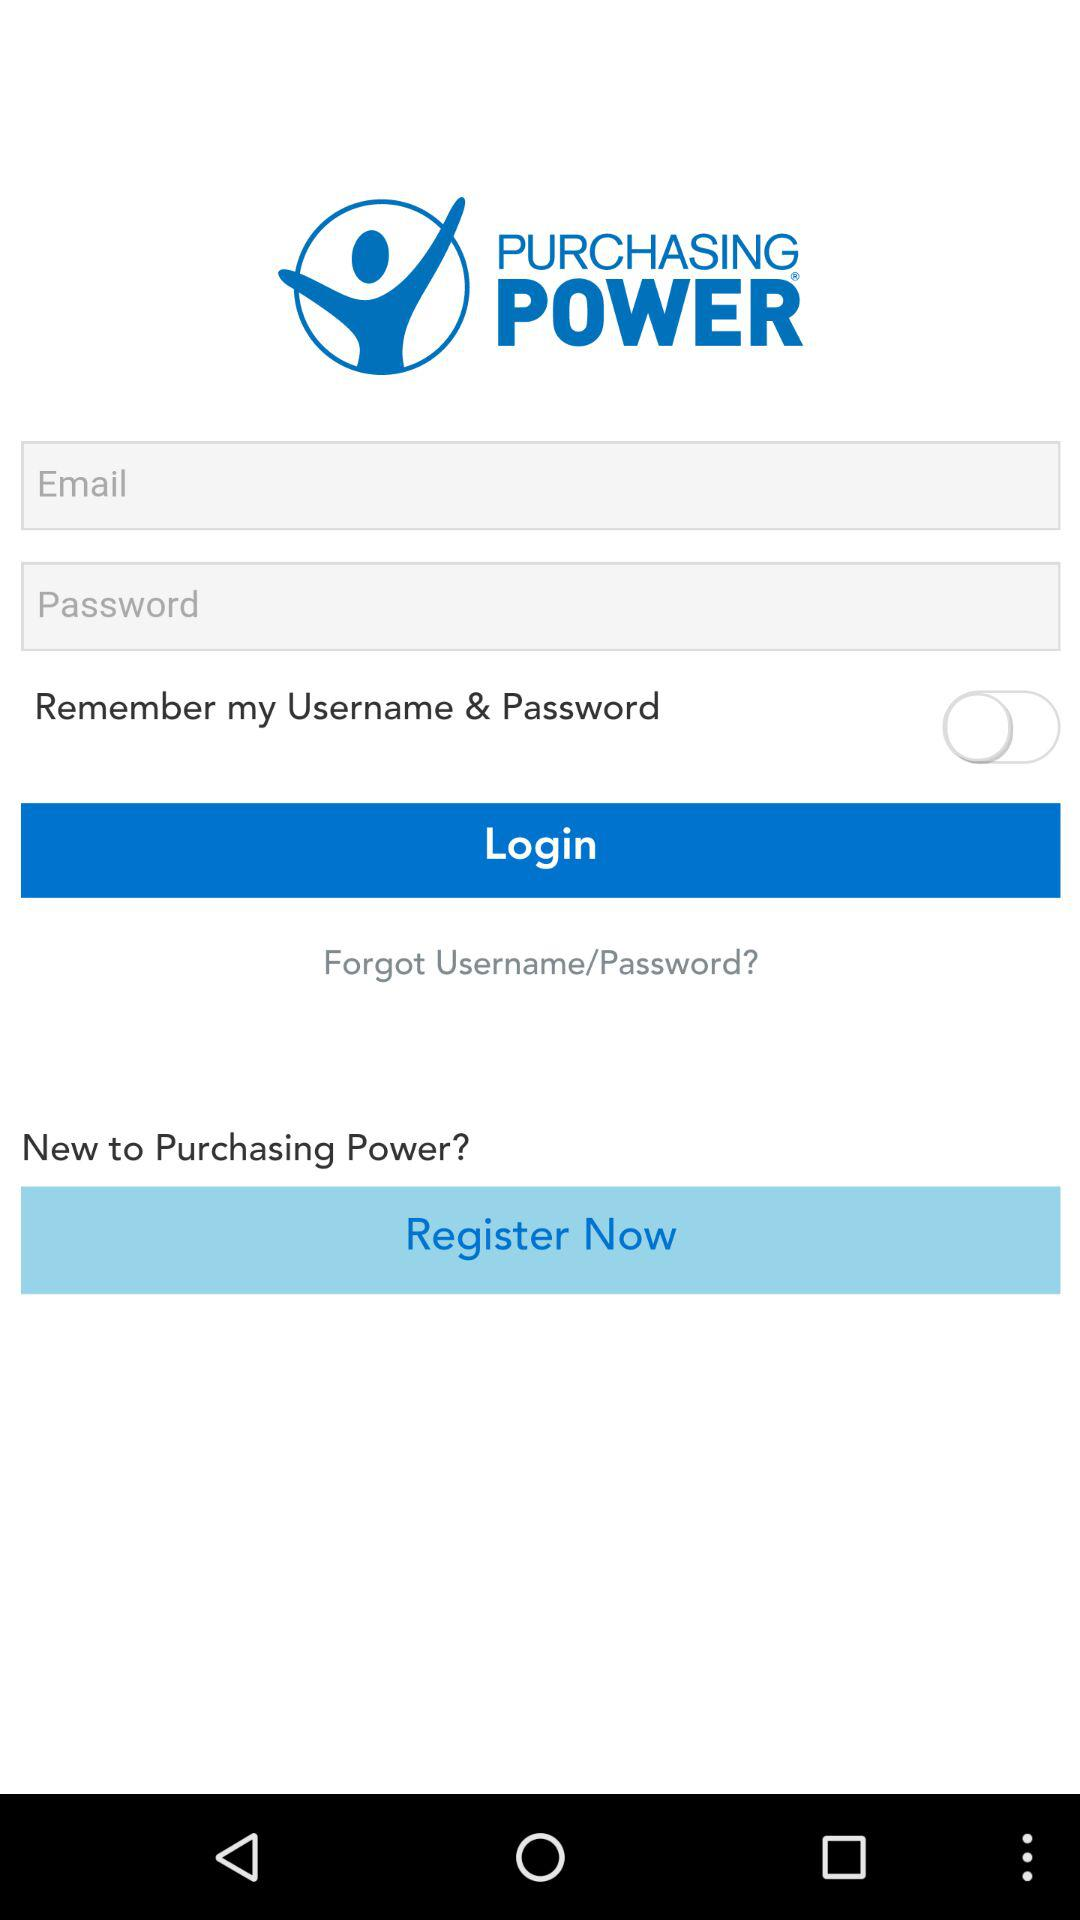What is the status of remembering my username and password? The status is "off". 